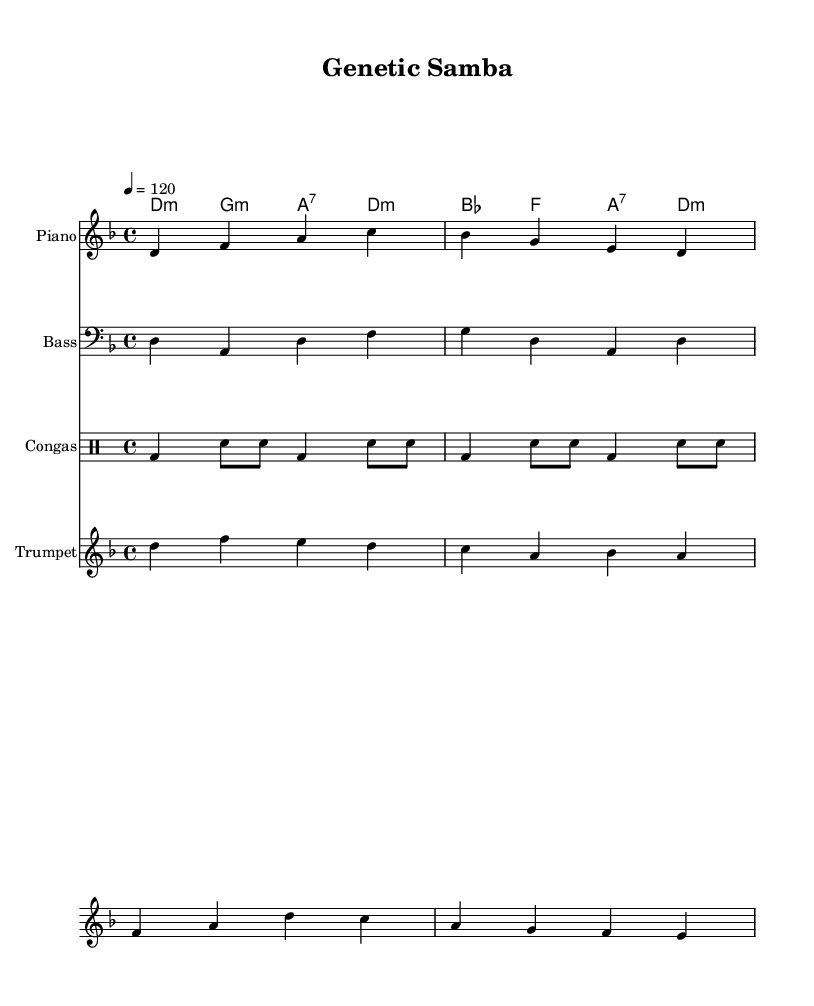What is the key signature of this music? The key signature is D minor, indicated by one flat (B flat), reflecting the tonality of the piece.
Answer: D minor What is the time signature of this piece? The time signature is 4/4, as shown at the beginning of the score; it indicates four beats in a measure, with a quarter note receiving one beat.
Answer: 4/4 What is the tempo marking for the piece? The tempo marking is 120 beats per minute, specified by "4 = 120", indicating the speed at which the music should be played.
Answer: 120 How many instruments are included in the score? There are four types of instruments specified: Piano, Bass, Congas, and Trumpet, as shown in the score layout.
Answer: Four What is the primary theme reflected in the lyrics? The lyrics emphasize genetic diversity, as they mention "Genes dancing in the code of life" and "Diversity in every strand," indicating a focus on biological themes.
Answer: Genetic diversity What type of chord is used at the start of the harmony? The first chord in the harmony is a D minor chord, as indicated by the notation in the chord mode section of the sheet music.
Answer: D minor What rhythmic pattern does the Congas section follow? The Congas section features a repeating pattern of a bass drum followed by snare hits, typical in Latin music for maintaining a rhythmic pulse.
Answer: Bass drum and snare pattern 